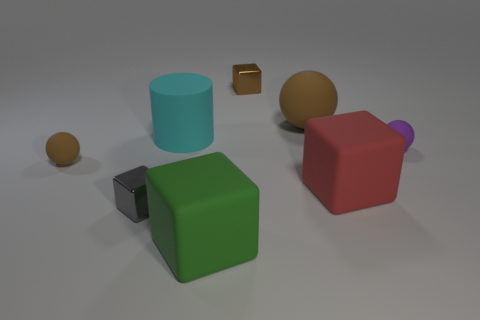Add 1 large green metallic balls. How many objects exist? 9 Subtract all balls. How many objects are left? 5 Add 2 rubber balls. How many rubber balls are left? 5 Add 4 matte cubes. How many matte cubes exist? 6 Subtract 0 red cylinders. How many objects are left? 8 Subtract all tiny gray shiny objects. Subtract all large cyan objects. How many objects are left? 6 